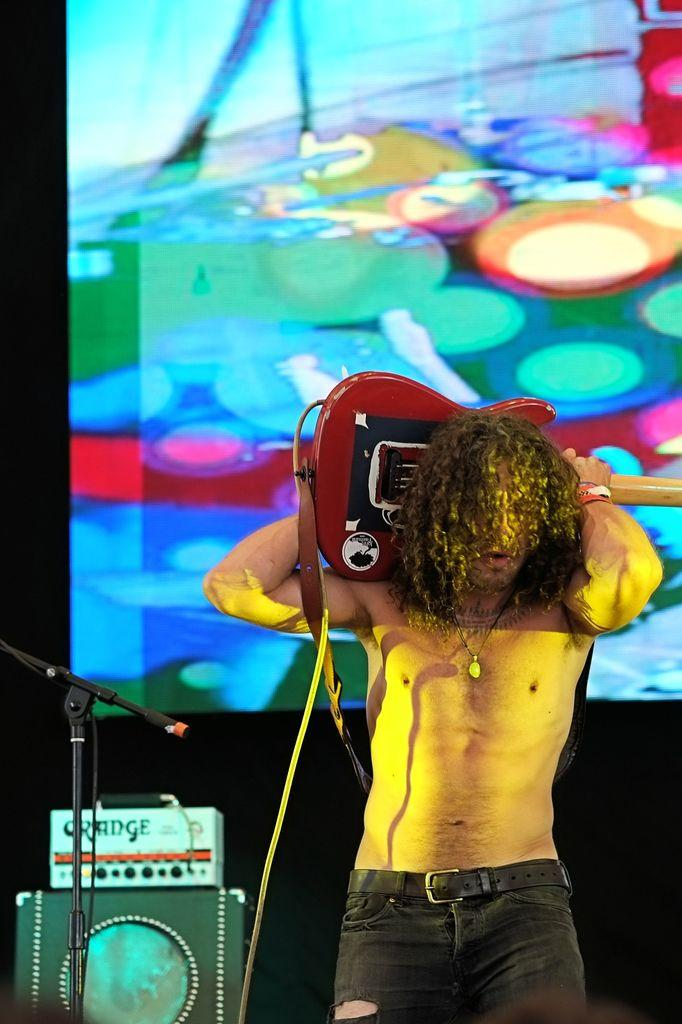What is the main subject of the image? There is a person in the image. What is the person doing in the image? The person is standing and holding a guitar. What object is beside the person? There is a microphone stand beside the person. What other objects can be seen beside the person? There are a few other objects beside the person. What can be seen in the background of the image? There is a screen in the background of the image. What type of vein is visible on the person's knee in the image? There is no visible vein on the person's knee in the image. What meal is the person eating in the image? The person is not eating a meal in the image; they are holding a guitar. 